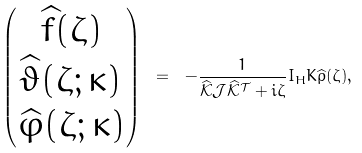Convert formula to latex. <formula><loc_0><loc_0><loc_500><loc_500>\begin{pmatrix} \widehat { f } ( \zeta ) \\ \widehat { \vartheta } ( \zeta ; \kappa ) \\ \widehat { \varphi } ( \zeta ; \kappa ) \end{pmatrix} \ = \ - \frac { 1 } { \mathcal { \widehat { K } J \widehat { K } ^ { T } } + i \zeta } I _ { H } K \widehat { \rho } ( \zeta ) ,</formula> 